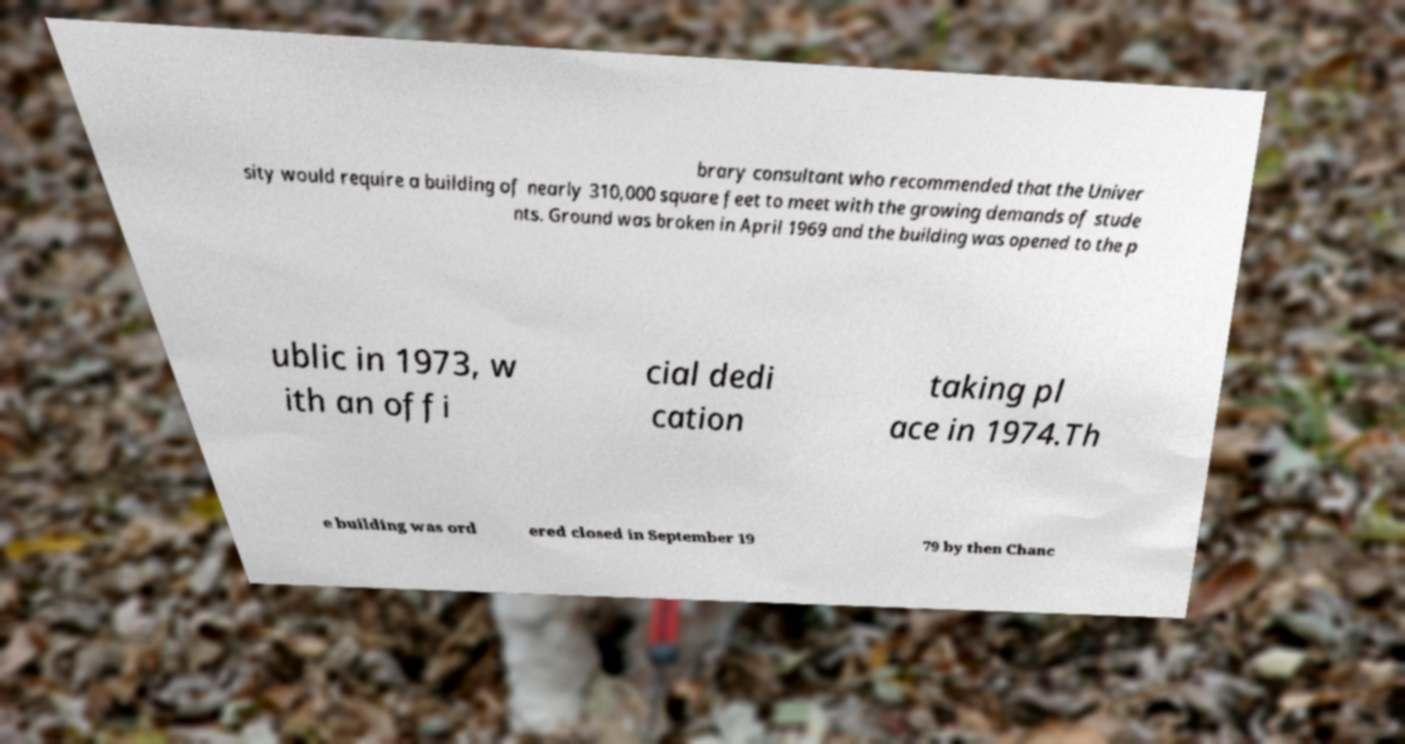Can you accurately transcribe the text from the provided image for me? brary consultant who recommended that the Univer sity would require a building of nearly 310,000 square feet to meet with the growing demands of stude nts. Ground was broken in April 1969 and the building was opened to the p ublic in 1973, w ith an offi cial dedi cation taking pl ace in 1974.Th e building was ord ered closed in September 19 79 by then Chanc 